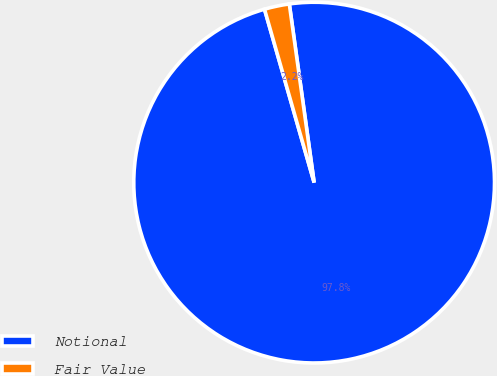Convert chart to OTSL. <chart><loc_0><loc_0><loc_500><loc_500><pie_chart><fcel>Notional<fcel>Fair Value<nl><fcel>97.76%<fcel>2.24%<nl></chart> 